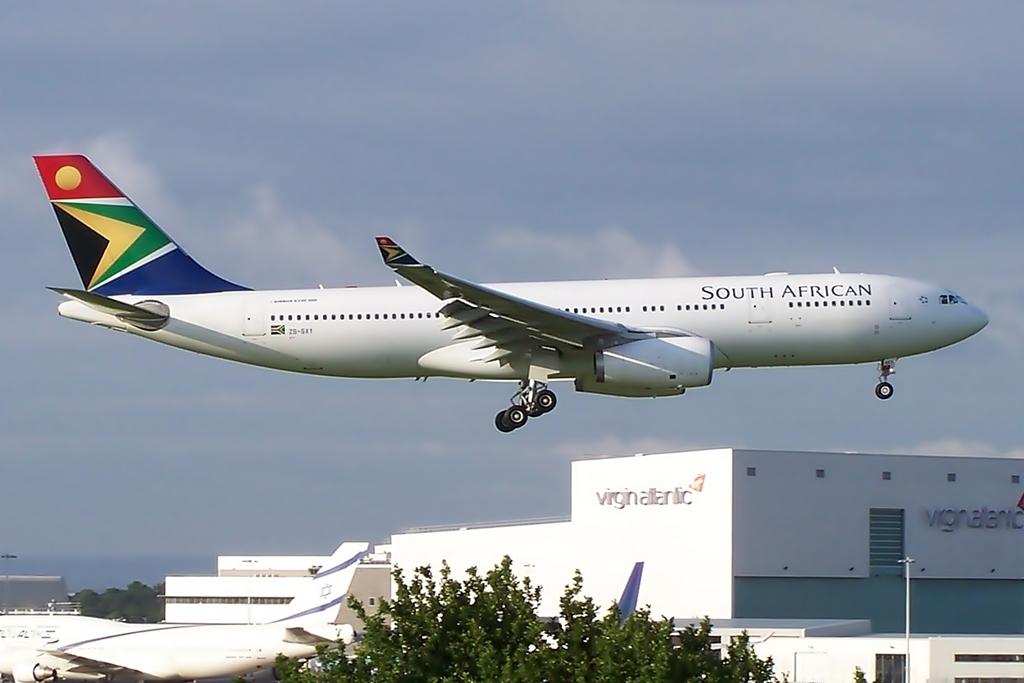Where is the plane going?
Offer a terse response. Unanswerable. What type of plane is this?
Offer a terse response. South african. 